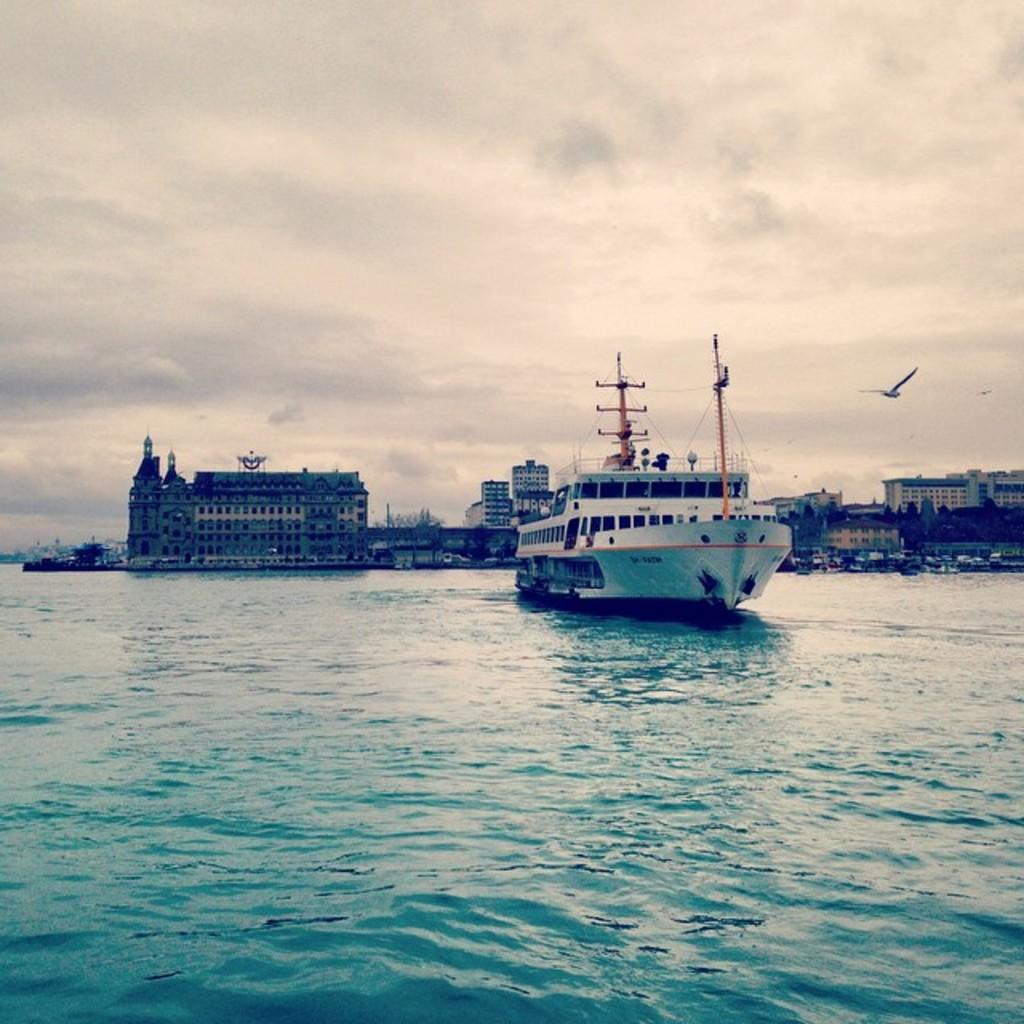What type of vessel is shown in the image? The image depicts a Cruise Ferry on the water. What else can be seen in the background of the image? There are buildings visible in the image. Are there any animals present in the image? Yes, a bird is flying in the image. What is visible above the water in the image? The sky is visible in the image. What type of agreement is being discussed by the people on the Cruise Ferry in the image? There are no people visible on the Cruise Ferry in the image, and therefore no discussion or agreement can be observed. What type of beef is being served on the Cruise Ferry in the image? There is no mention of food or beef in the image; it only shows a Cruise Ferry on the water. 